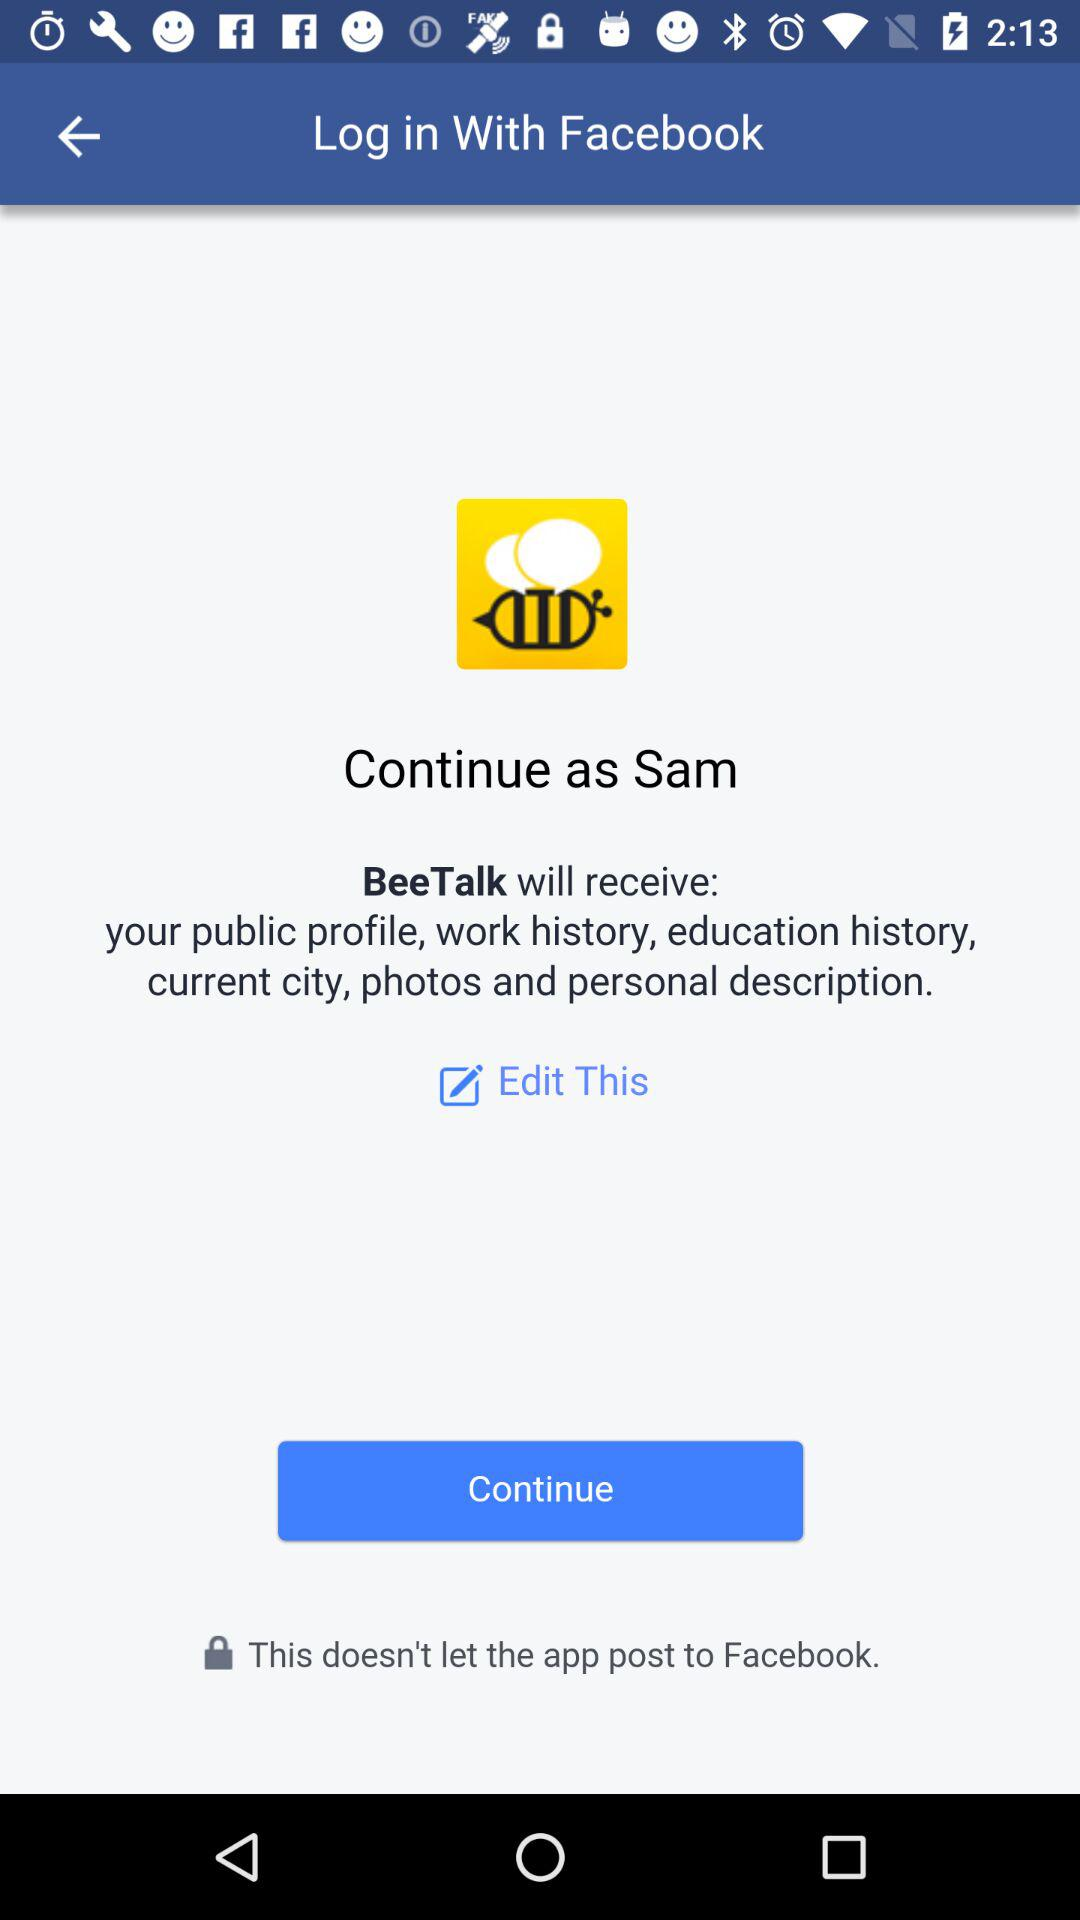What account can logging in be done with? Logging in can be done with "Facebook". 